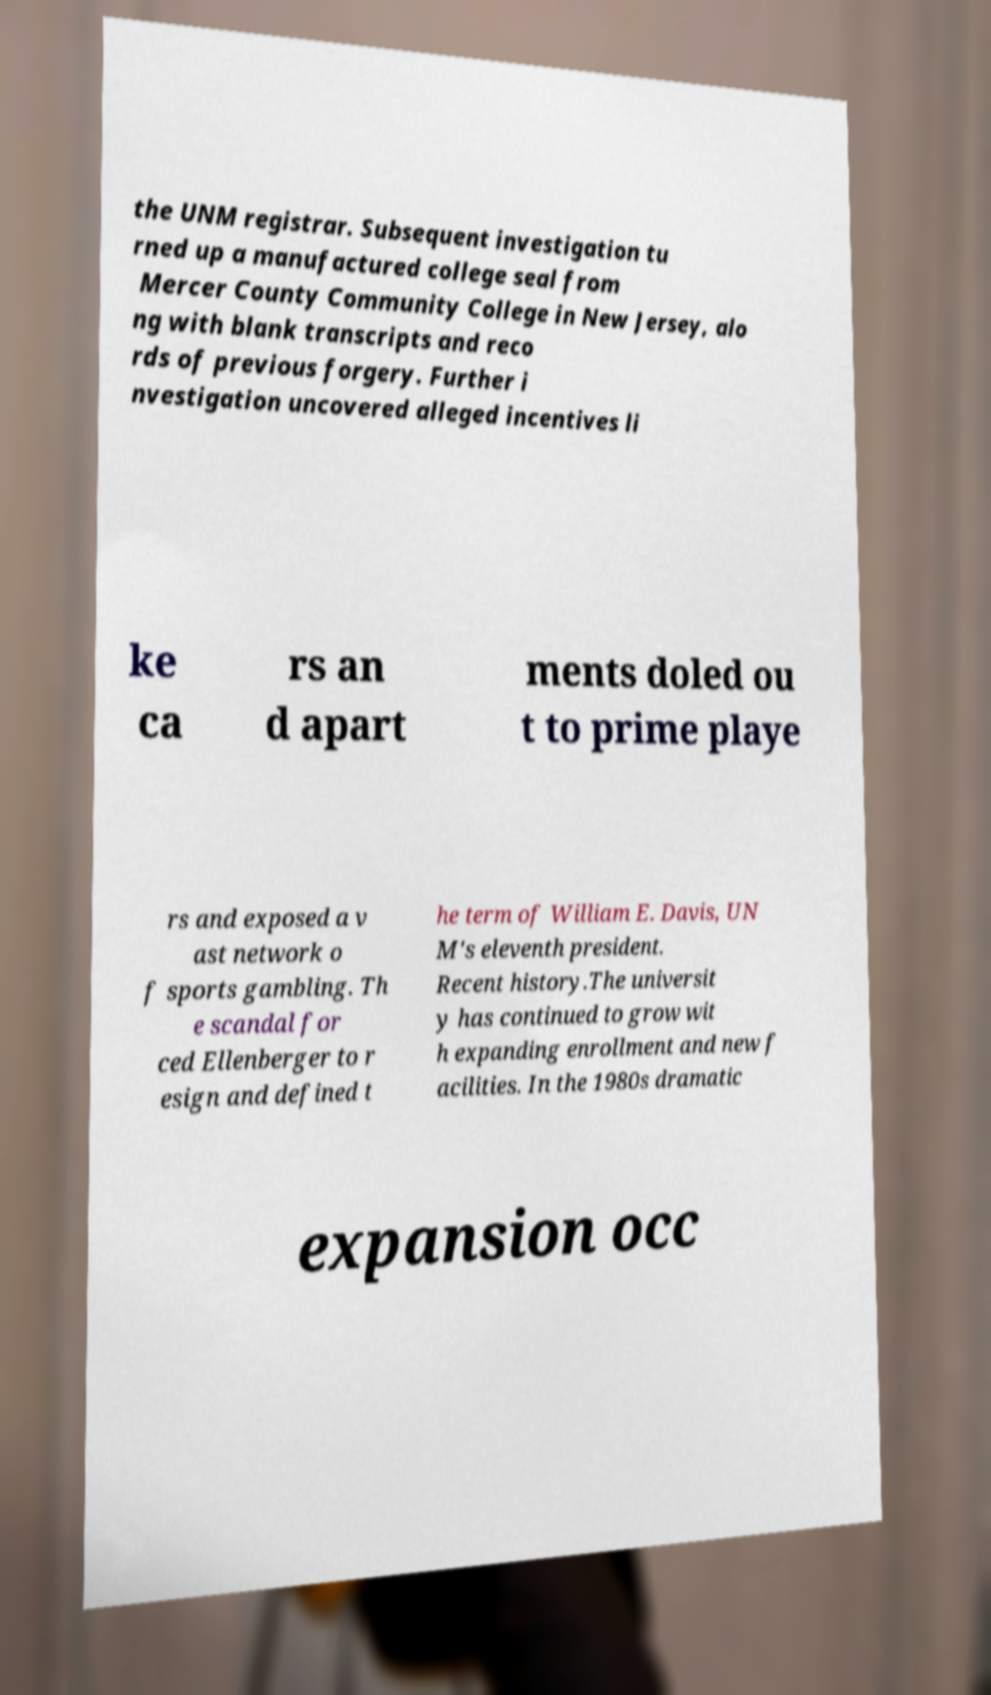Can you read and provide the text displayed in the image?This photo seems to have some interesting text. Can you extract and type it out for me? the UNM registrar. Subsequent investigation tu rned up a manufactured college seal from Mercer County Community College in New Jersey, alo ng with blank transcripts and reco rds of previous forgery. Further i nvestigation uncovered alleged incentives li ke ca rs an d apart ments doled ou t to prime playe rs and exposed a v ast network o f sports gambling. Th e scandal for ced Ellenberger to r esign and defined t he term of William E. Davis, UN M's eleventh president. Recent history.The universit y has continued to grow wit h expanding enrollment and new f acilities. In the 1980s dramatic expansion occ 